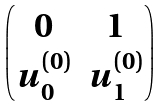<formula> <loc_0><loc_0><loc_500><loc_500>\begin{pmatrix} 0 & 1 \\ u _ { 0 } ^ { ( 0 ) } & u _ { 1 } ^ { ( 0 ) } \\ \end{pmatrix}</formula> 